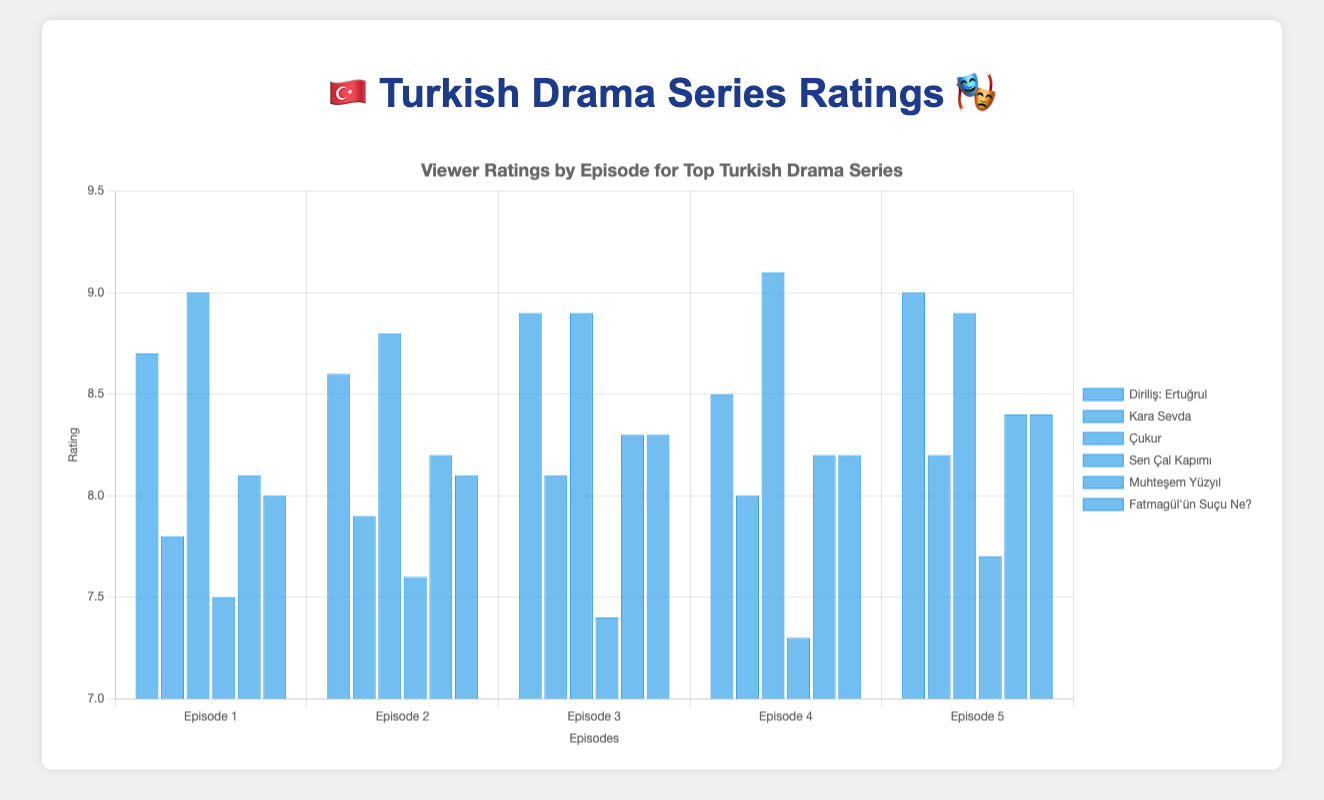What's the highest rating achieved by "Diriliş: Ertuğrul" and in which episode? The highest rating achieved by "Diriliş: Ertuğrul" is given by the height of the highest bar for that series. We scan through the bars and find that Episode 5 has the highest rating of 9.0.
Answer: 9.0, Episode 5 By how much does the highest rating of "Çukur" exceed the highest rating of "Kara Sevda"? We identify the highest rating of each series: 
- Highest rating of "Çukur" is 9.1 
- Highest rating of "Kara Sevda" is 8.2 
The difference is 9.1 - 8.2 = 0.9.
Answer: 0.9 Which episode of "Sen Çal Kapımı" has the lowest rating, and what is that rating? The lowest rating for "Sen Çal Kapımı" can be identified by the shortest bar. Episode 4 has the lowest rating of 7.3.
Answer: Episode 4, 7.3 What is the total sum of the ratings for "Fatmagül'ün Suçu Ne?"? Add the ratings of all episodes for "Fatmagül'ün Suçu Ne?": 
8.0 + 8.1 + 8.3 + 8.2 + 8.4 = 41.0.
Answer: 41.0 